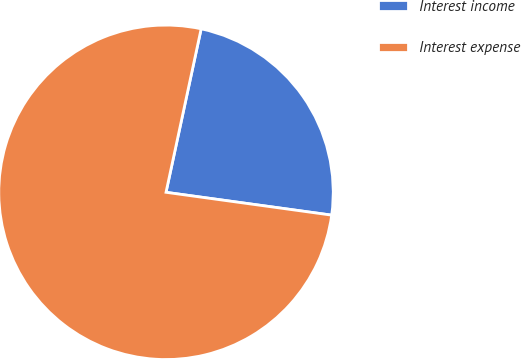<chart> <loc_0><loc_0><loc_500><loc_500><pie_chart><fcel>Interest income<fcel>Interest expense<nl><fcel>23.81%<fcel>76.19%<nl></chart> 